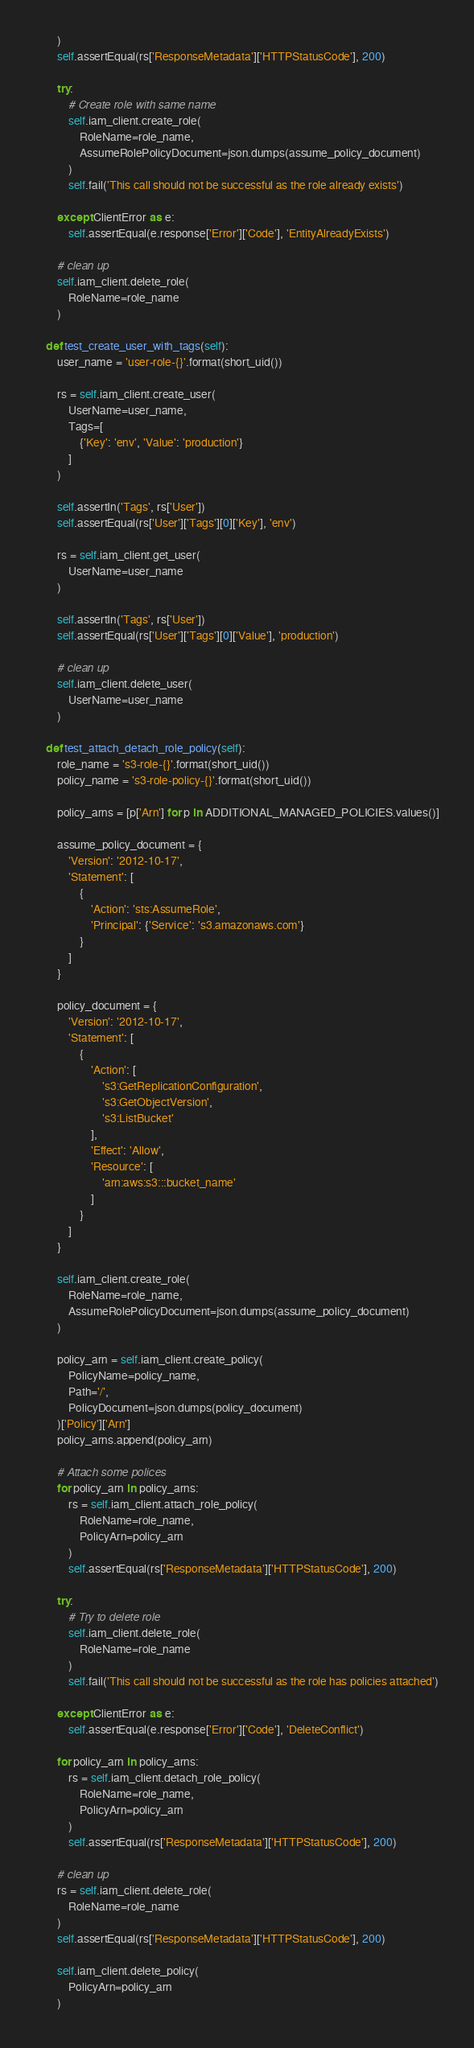<code> <loc_0><loc_0><loc_500><loc_500><_Python_>        )
        self.assertEqual(rs['ResponseMetadata']['HTTPStatusCode'], 200)

        try:
            # Create role with same name
            self.iam_client.create_role(
                RoleName=role_name,
                AssumeRolePolicyDocument=json.dumps(assume_policy_document)
            )
            self.fail('This call should not be successful as the role already exists')

        except ClientError as e:
            self.assertEqual(e.response['Error']['Code'], 'EntityAlreadyExists')

        # clean up
        self.iam_client.delete_role(
            RoleName=role_name
        )

    def test_create_user_with_tags(self):
        user_name = 'user-role-{}'.format(short_uid())

        rs = self.iam_client.create_user(
            UserName=user_name,
            Tags=[
                {'Key': 'env', 'Value': 'production'}
            ]
        )

        self.assertIn('Tags', rs['User'])
        self.assertEqual(rs['User']['Tags'][0]['Key'], 'env')

        rs = self.iam_client.get_user(
            UserName=user_name
        )

        self.assertIn('Tags', rs['User'])
        self.assertEqual(rs['User']['Tags'][0]['Value'], 'production')

        # clean up
        self.iam_client.delete_user(
            UserName=user_name
        )

    def test_attach_detach_role_policy(self):
        role_name = 's3-role-{}'.format(short_uid())
        policy_name = 's3-role-policy-{}'.format(short_uid())

        policy_arns = [p['Arn'] for p in ADDITIONAL_MANAGED_POLICIES.values()]

        assume_policy_document = {
            'Version': '2012-10-17',
            'Statement': [
                {
                    'Action': 'sts:AssumeRole',
                    'Principal': {'Service': 's3.amazonaws.com'}
                }
            ]
        }

        policy_document = {
            'Version': '2012-10-17',
            'Statement': [
                {
                    'Action': [
                        's3:GetReplicationConfiguration',
                        's3:GetObjectVersion',
                        's3:ListBucket'
                    ],
                    'Effect': 'Allow',
                    'Resource': [
                        'arn:aws:s3:::bucket_name'
                    ]
                }
            ]
        }

        self.iam_client.create_role(
            RoleName=role_name,
            AssumeRolePolicyDocument=json.dumps(assume_policy_document)
        )

        policy_arn = self.iam_client.create_policy(
            PolicyName=policy_name,
            Path='/',
            PolicyDocument=json.dumps(policy_document)
        )['Policy']['Arn']
        policy_arns.append(policy_arn)

        # Attach some polices
        for policy_arn in policy_arns:
            rs = self.iam_client.attach_role_policy(
                RoleName=role_name,
                PolicyArn=policy_arn
            )
            self.assertEqual(rs['ResponseMetadata']['HTTPStatusCode'], 200)

        try:
            # Try to delete role
            self.iam_client.delete_role(
                RoleName=role_name
            )
            self.fail('This call should not be successful as the role has policies attached')

        except ClientError as e:
            self.assertEqual(e.response['Error']['Code'], 'DeleteConflict')

        for policy_arn in policy_arns:
            rs = self.iam_client.detach_role_policy(
                RoleName=role_name,
                PolicyArn=policy_arn
            )
            self.assertEqual(rs['ResponseMetadata']['HTTPStatusCode'], 200)

        # clean up
        rs = self.iam_client.delete_role(
            RoleName=role_name
        )
        self.assertEqual(rs['ResponseMetadata']['HTTPStatusCode'], 200)

        self.iam_client.delete_policy(
            PolicyArn=policy_arn
        )
</code> 